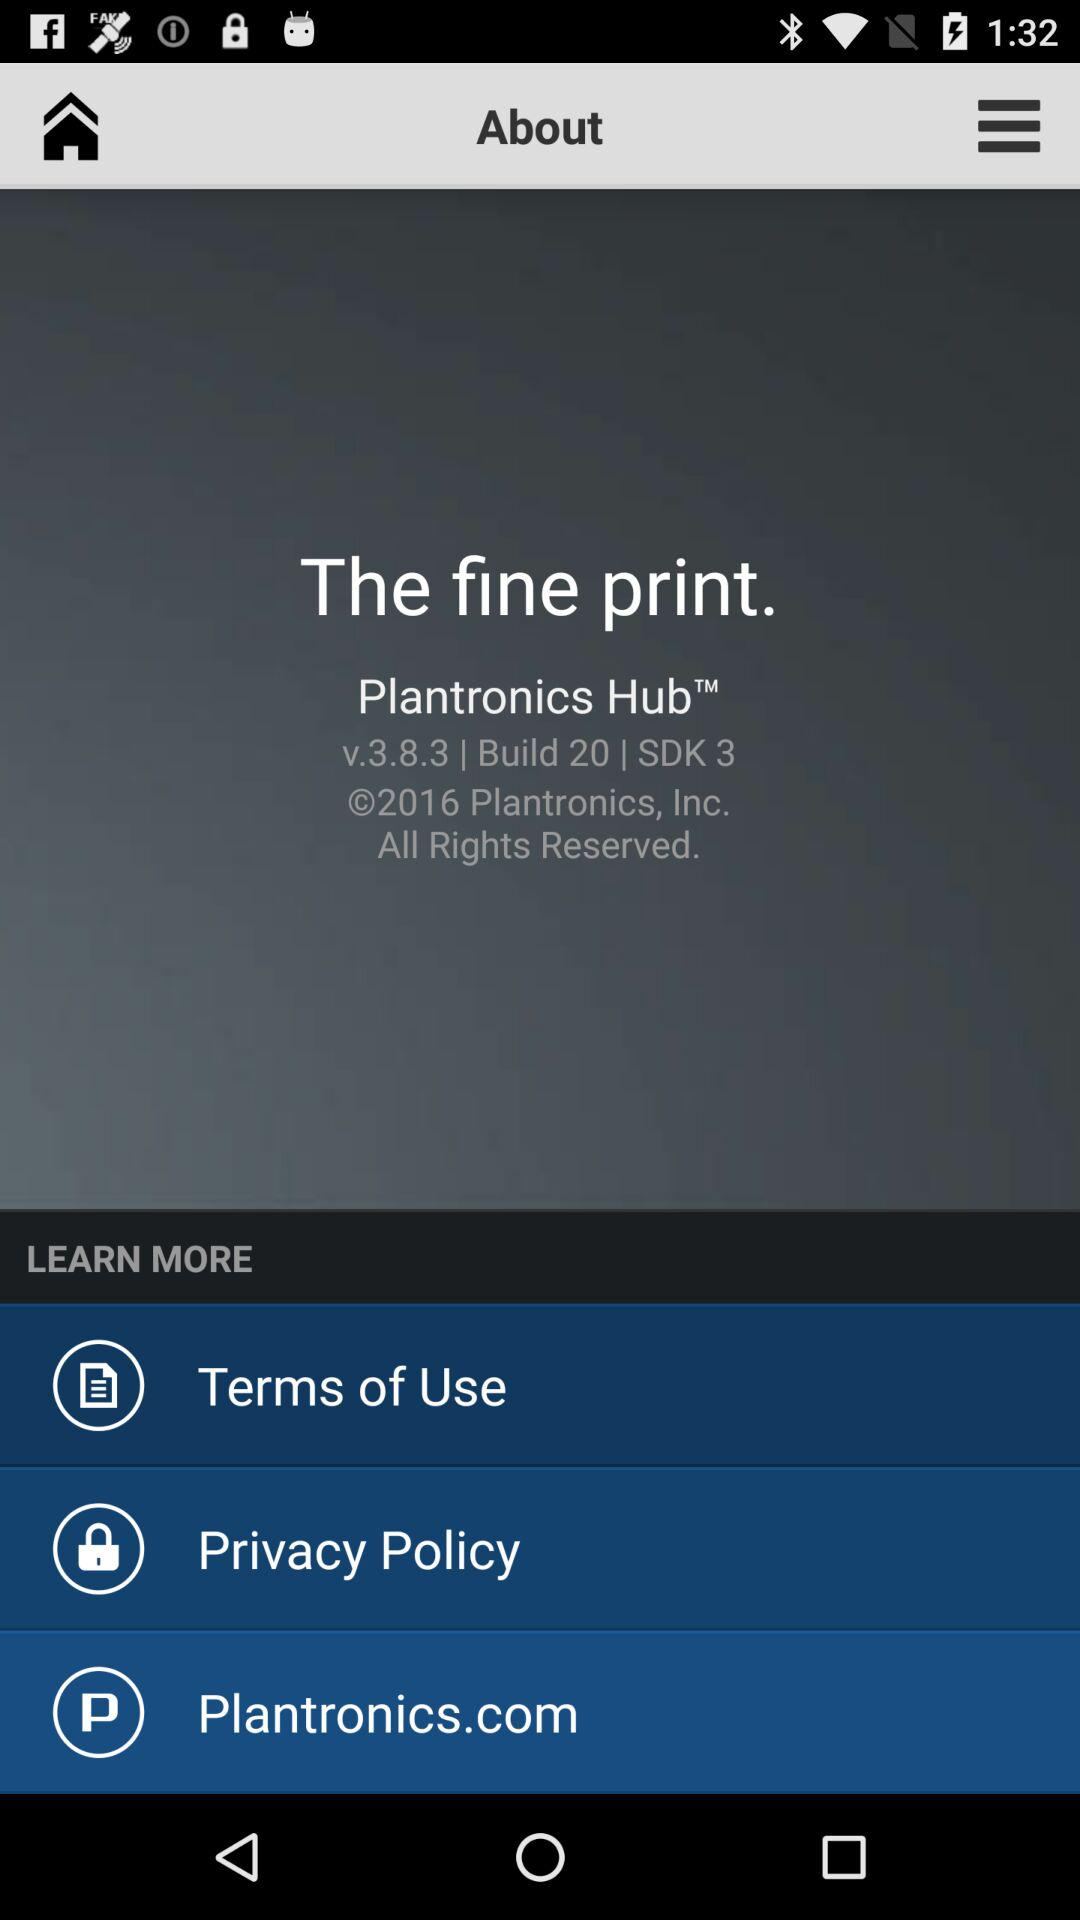What is the application name? The application name is "Plantronics Hub". 